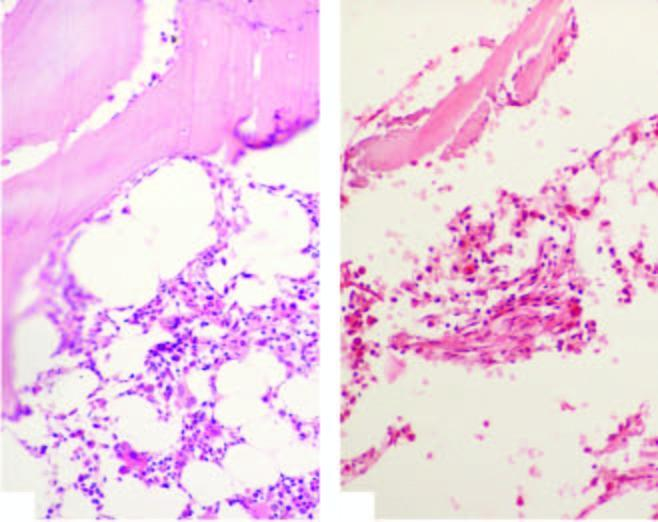does the biopsy show suppression of myeloid and erythroid cells and replacement of haematopoetic elements by fat in aplastic anaemia?
Answer the question using a single word or phrase. Yes 